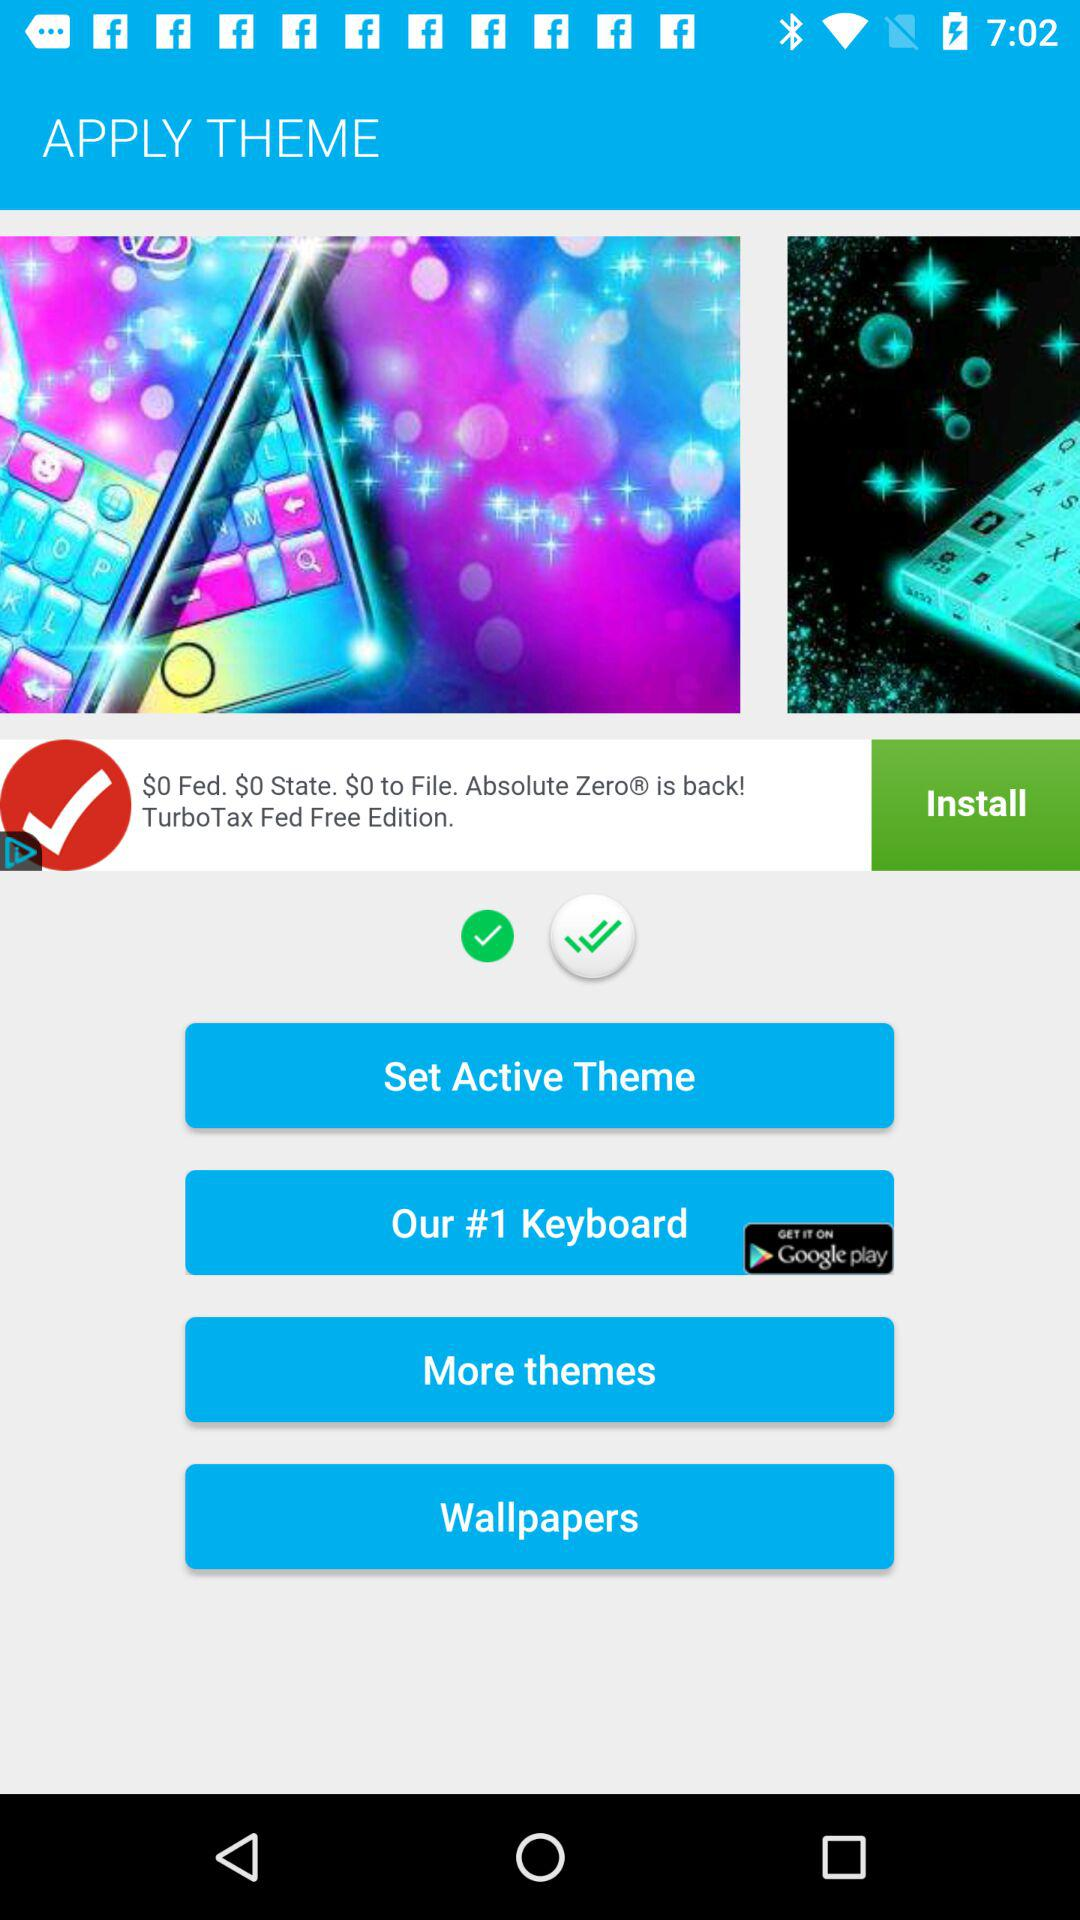What's the number of keyboard Theme?
When the provided information is insufficient, respond with <no answer>. <no answer> 